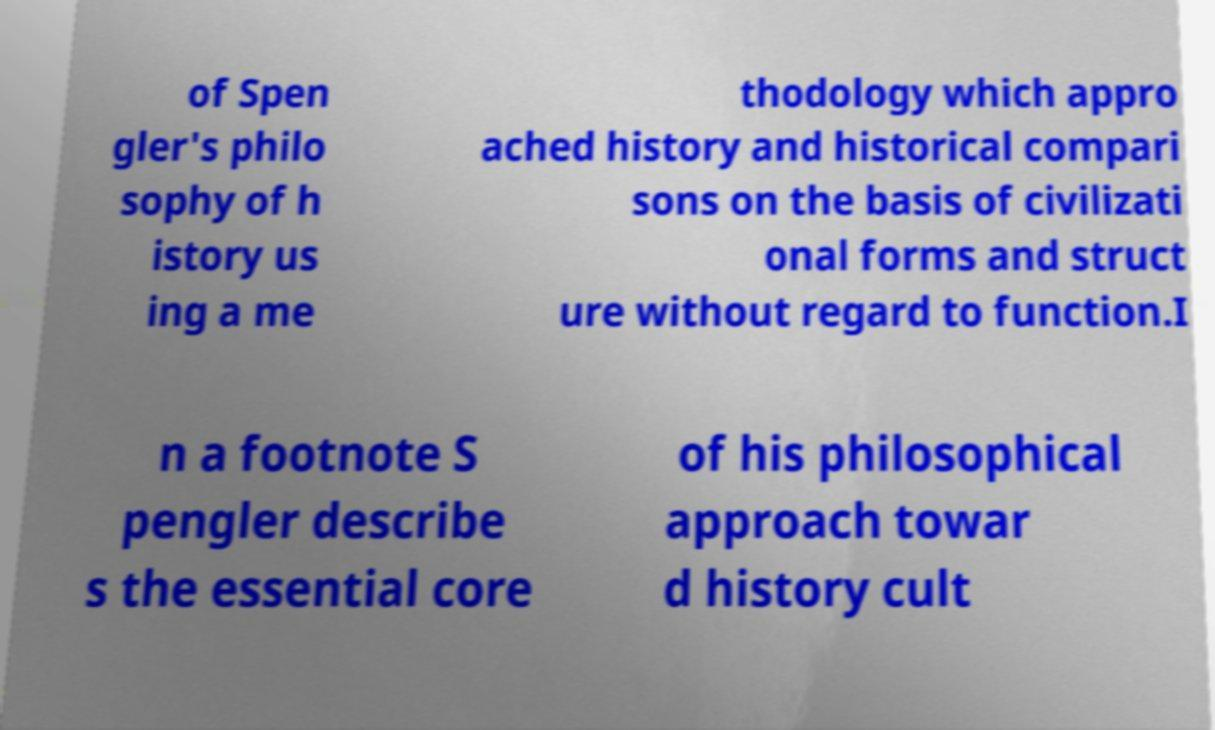Please read and relay the text visible in this image. What does it say? of Spen gler's philo sophy of h istory us ing a me thodology which appro ached history and historical compari sons on the basis of civilizati onal forms and struct ure without regard to function.I n a footnote S pengler describe s the essential core of his philosophical approach towar d history cult 